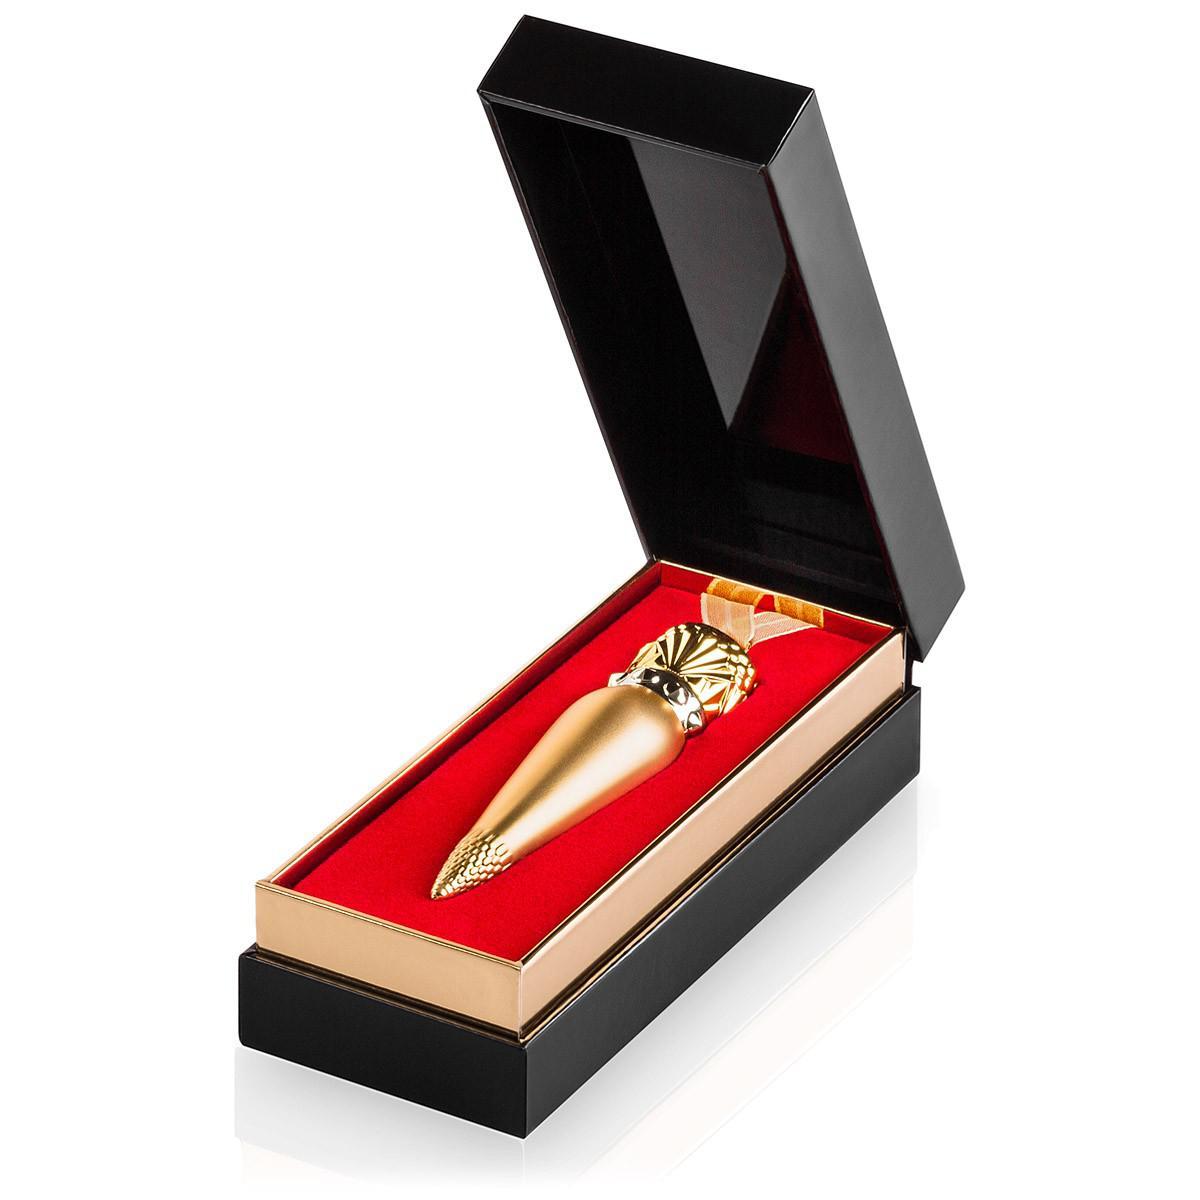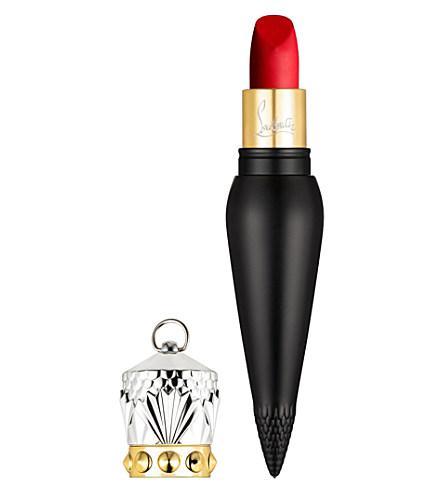The first image is the image on the left, the second image is the image on the right. Assess this claim about the two images: "There are three lipsticks with black cases in at least one image.". Correct or not? Answer yes or no. No. The first image is the image on the left, the second image is the image on the right. Evaluate the accuracy of this statement regarding the images: "Lipstick in a black and gold vial shaped tube is balanced upright on the tip and has a cap that resembles a crown set down next to it.". Is it true? Answer yes or no. Yes. 